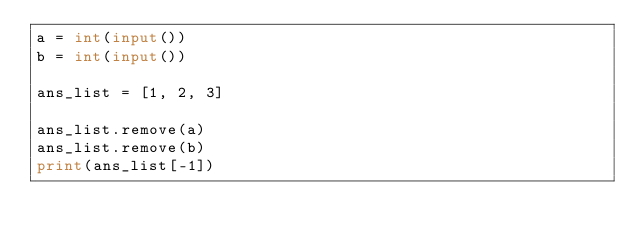Convert code to text. <code><loc_0><loc_0><loc_500><loc_500><_Python_>a = int(input())
b = int(input())

ans_list = [1, 2, 3]

ans_list.remove(a)
ans_list.remove(b)
print(ans_list[-1])</code> 